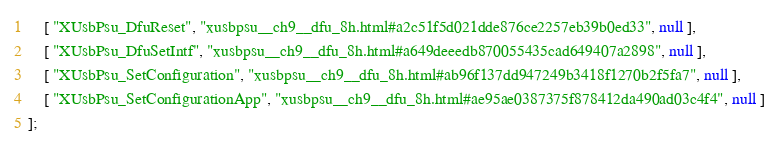<code> <loc_0><loc_0><loc_500><loc_500><_JavaScript_>    [ "XUsbPsu_DfuReset", "xusbpsu__ch9__dfu_8h.html#a2c51f5d021dde876ce2257eb39b0ed33", null ],
    [ "XUsbPsu_DfuSetIntf", "xusbpsu__ch9__dfu_8h.html#a649deeedb870055435cad649407a2898", null ],
    [ "XUsbPsu_SetConfiguration", "xusbpsu__ch9__dfu_8h.html#ab96f137dd947249b3418f1270b2f5fa7", null ],
    [ "XUsbPsu_SetConfigurationApp", "xusbpsu__ch9__dfu_8h.html#ae95ae0387375f878412da490ad03c4f4", null ]
];</code> 